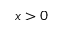Convert formula to latex. <formula><loc_0><loc_0><loc_500><loc_500>x > 0</formula> 